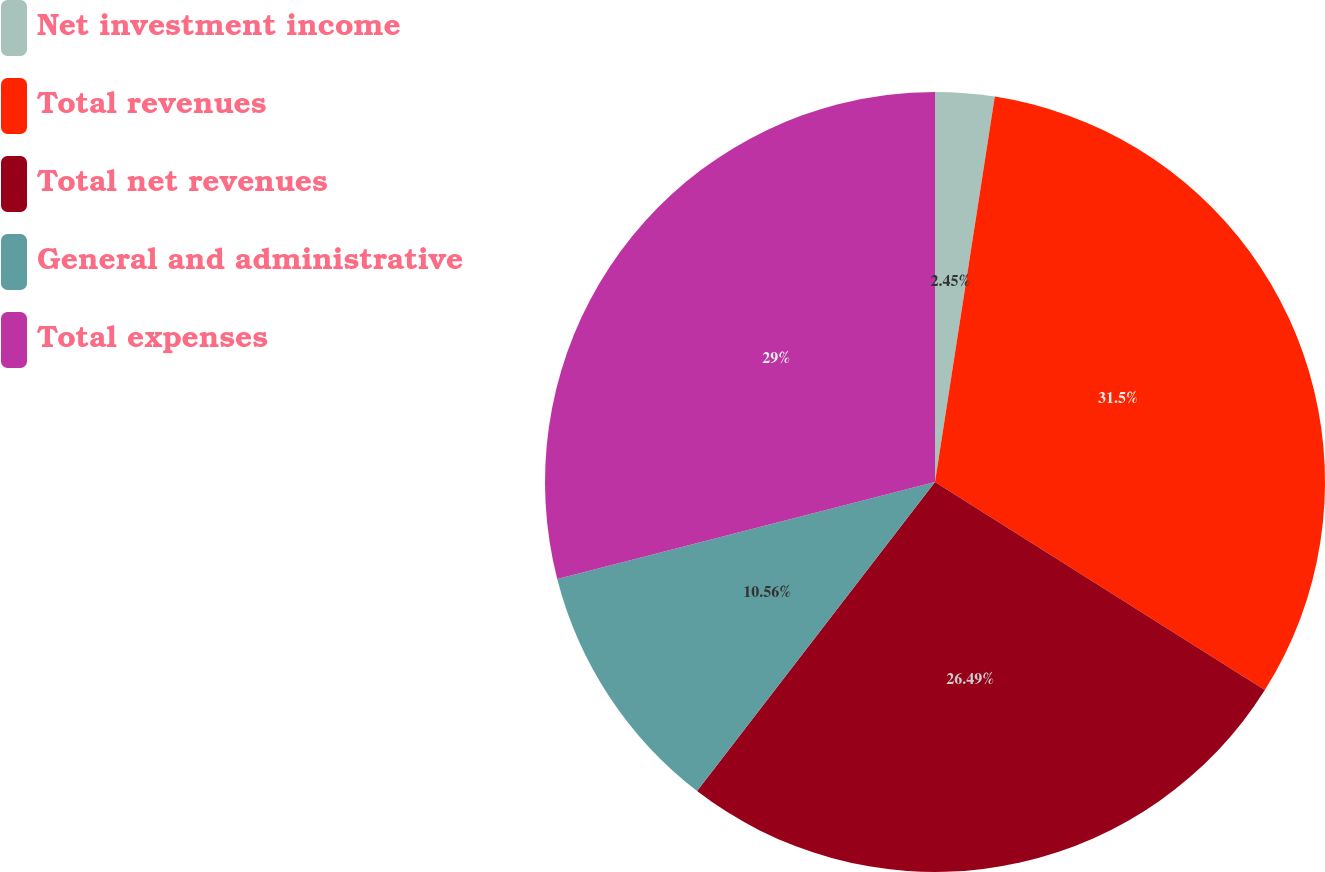<chart> <loc_0><loc_0><loc_500><loc_500><pie_chart><fcel>Net investment income<fcel>Total revenues<fcel>Total net revenues<fcel>General and administrative<fcel>Total expenses<nl><fcel>2.45%<fcel>31.51%<fcel>26.49%<fcel>10.56%<fcel>29.0%<nl></chart> 